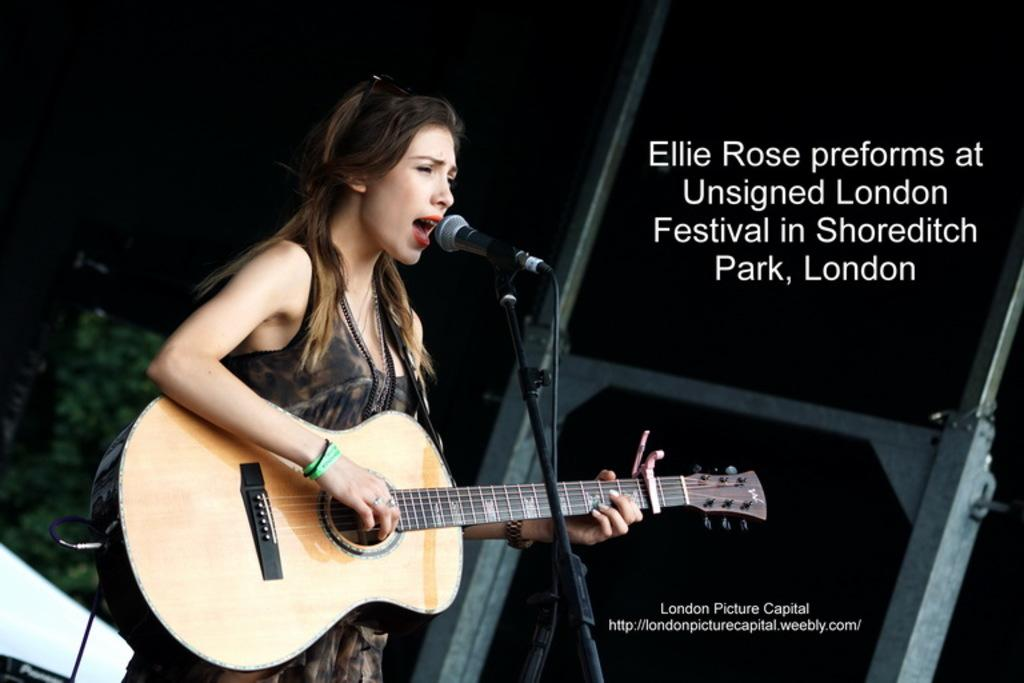What is the woman in the image doing? The woman is playing a guitar and singing into a microphone. What instrument is the woman playing in the image? The woman is playing a guitar. What can be seen in the background of the image? There is a banner in the background of the image. What type of potato is the woman using as a prop in the image? There is no potato present in the image; the woman is playing a guitar and singing into a microphone. How does the woman's nervous system affect her performance in the image? The provided facts do not mention anything about the woman's nervous system, so it is impossible to determine its effect on her performance. 